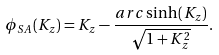Convert formula to latex. <formula><loc_0><loc_0><loc_500><loc_500>\phi _ { S A } ( K _ { z } ) = K _ { z } - \frac { a r c \sinh \left ( K _ { z } \right ) } { \sqrt { 1 + K _ { z } ^ { 2 } } } .</formula> 